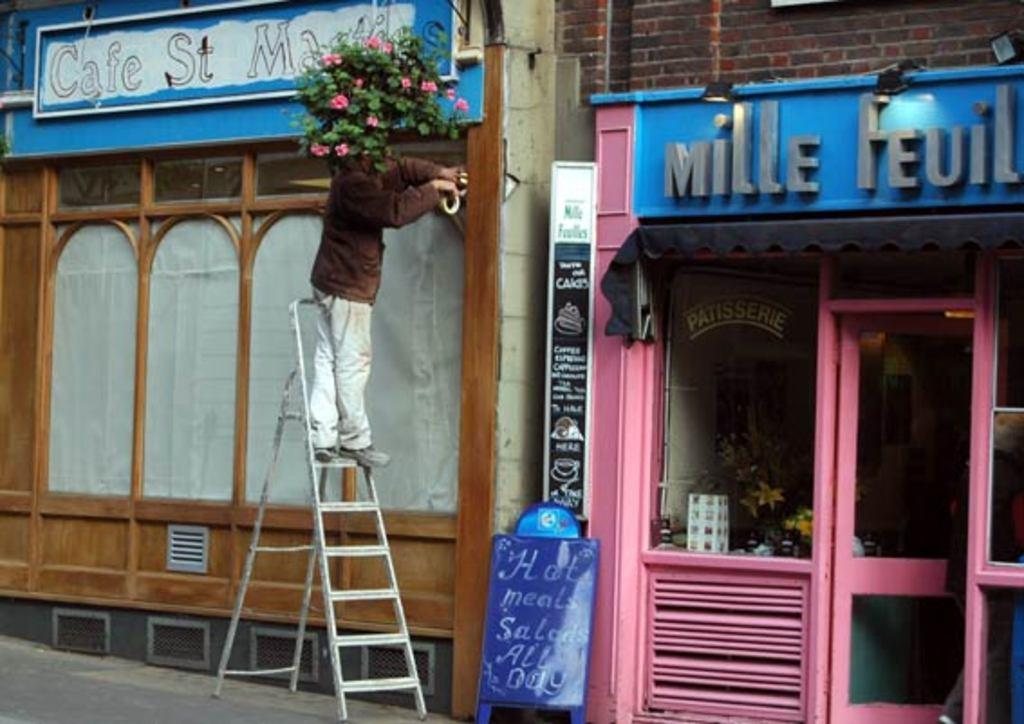<image>
Create a compact narrative representing the image presented. a person on a ladder under a cafe sign 